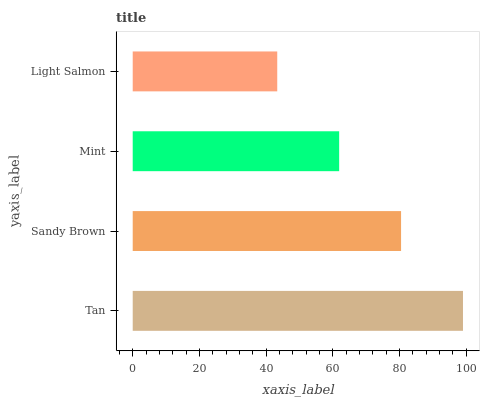Is Light Salmon the minimum?
Answer yes or no. Yes. Is Tan the maximum?
Answer yes or no. Yes. Is Sandy Brown the minimum?
Answer yes or no. No. Is Sandy Brown the maximum?
Answer yes or no. No. Is Tan greater than Sandy Brown?
Answer yes or no. Yes. Is Sandy Brown less than Tan?
Answer yes or no. Yes. Is Sandy Brown greater than Tan?
Answer yes or no. No. Is Tan less than Sandy Brown?
Answer yes or no. No. Is Sandy Brown the high median?
Answer yes or no. Yes. Is Mint the low median?
Answer yes or no. Yes. Is Tan the high median?
Answer yes or no. No. Is Tan the low median?
Answer yes or no. No. 